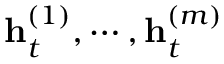Convert formula to latex. <formula><loc_0><loc_0><loc_500><loc_500>h _ { t } ^ { ( 1 ) } , \cdots , h _ { t } ^ { ( m ) }</formula> 